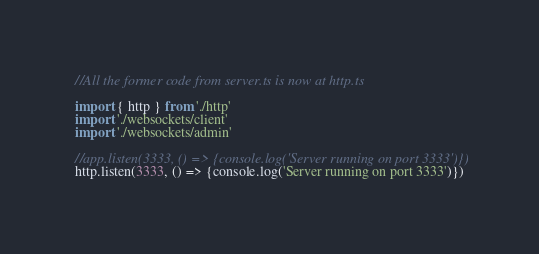Convert code to text. <code><loc_0><loc_0><loc_500><loc_500><_TypeScript_>
//All the former code from server.ts is now at http.ts

import { http } from './http'
import './websockets/client'
import './websockets/admin'

//app.listen(3333, () => {console.log('Server running on port 3333')})
http.listen(3333, () => {console.log('Server running on port 3333')})
</code> 